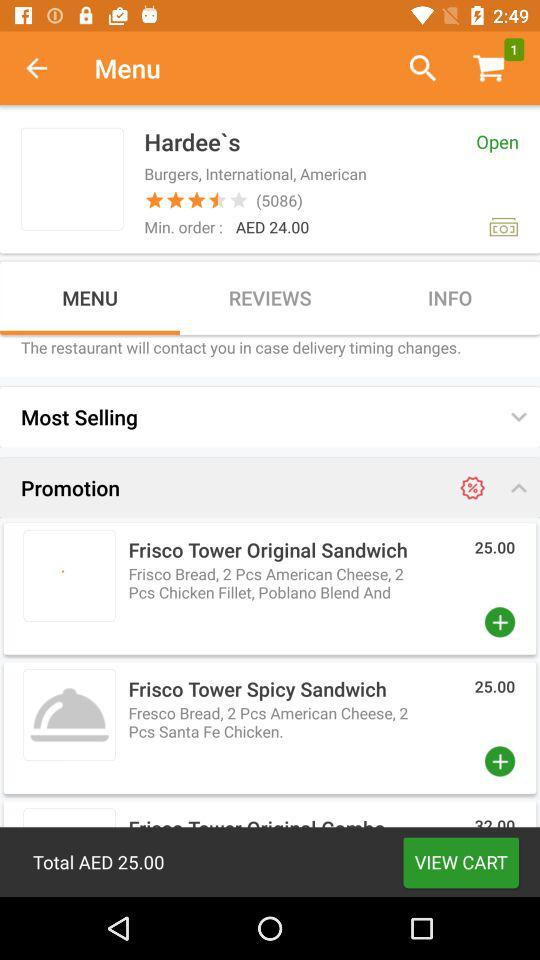How many reviews are given to "Hardee's"? The review given is 5086. 